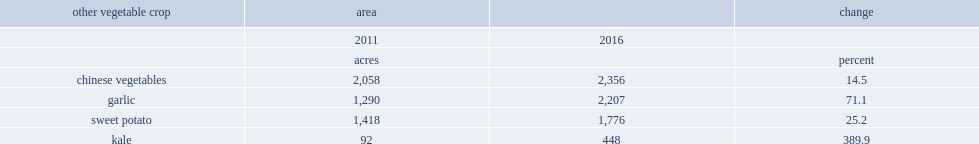How many times does kale crop area increase from 2011 to 2016? 4.869565. How many acres is the total kale crop area in 2016? 448. What is the percentage of the increase in sweet potato farms area from 2011 to 2016? 25.2. How many acres of sweet potato farms area were increased in 2016? 1776. 